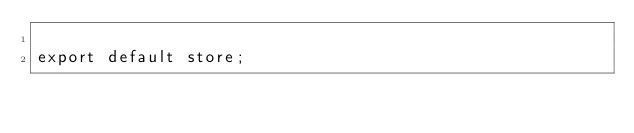<code> <loc_0><loc_0><loc_500><loc_500><_JavaScript_>
export default store;
</code> 